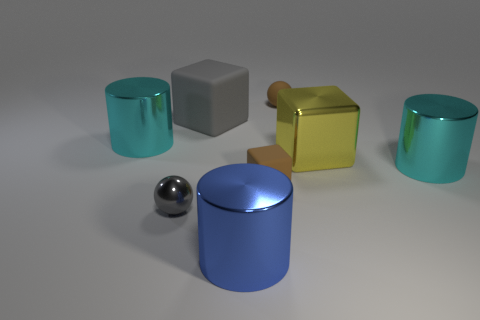What number of blocks are the same color as the tiny shiny ball?
Provide a succinct answer. 1. How big is the brown rubber object in front of the tiny brown thing right of the tiny brown thing that is in front of the big rubber block?
Ensure brevity in your answer.  Small. There is a large yellow thing; is its shape the same as the large cyan thing behind the big yellow block?
Offer a very short reply. No. There is a brown rubber object that is the same shape as the yellow metallic object; what size is it?
Provide a short and direct response. Small. How many other things are there of the same material as the small gray ball?
Make the answer very short. 4. What material is the gray sphere?
Make the answer very short. Metal. There is a metallic cylinder that is to the right of the blue metallic object; does it have the same color as the cylinder that is to the left of the blue cylinder?
Provide a short and direct response. Yes. Are there more yellow metallic things that are to the right of the big gray thing than purple rubber objects?
Make the answer very short. Yes. What number of other objects are the same color as the metallic cube?
Offer a very short reply. 0. There is a rubber block that is to the left of the brown rubber block; is its size the same as the brown cube?
Offer a very short reply. No. 